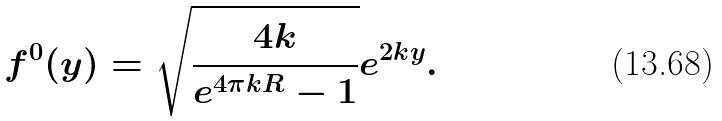<formula> <loc_0><loc_0><loc_500><loc_500>f ^ { 0 } ( y ) = \sqrt { \frac { 4 k } { e ^ { 4 \pi k R } - 1 } } e ^ { 2 k y } .</formula> 